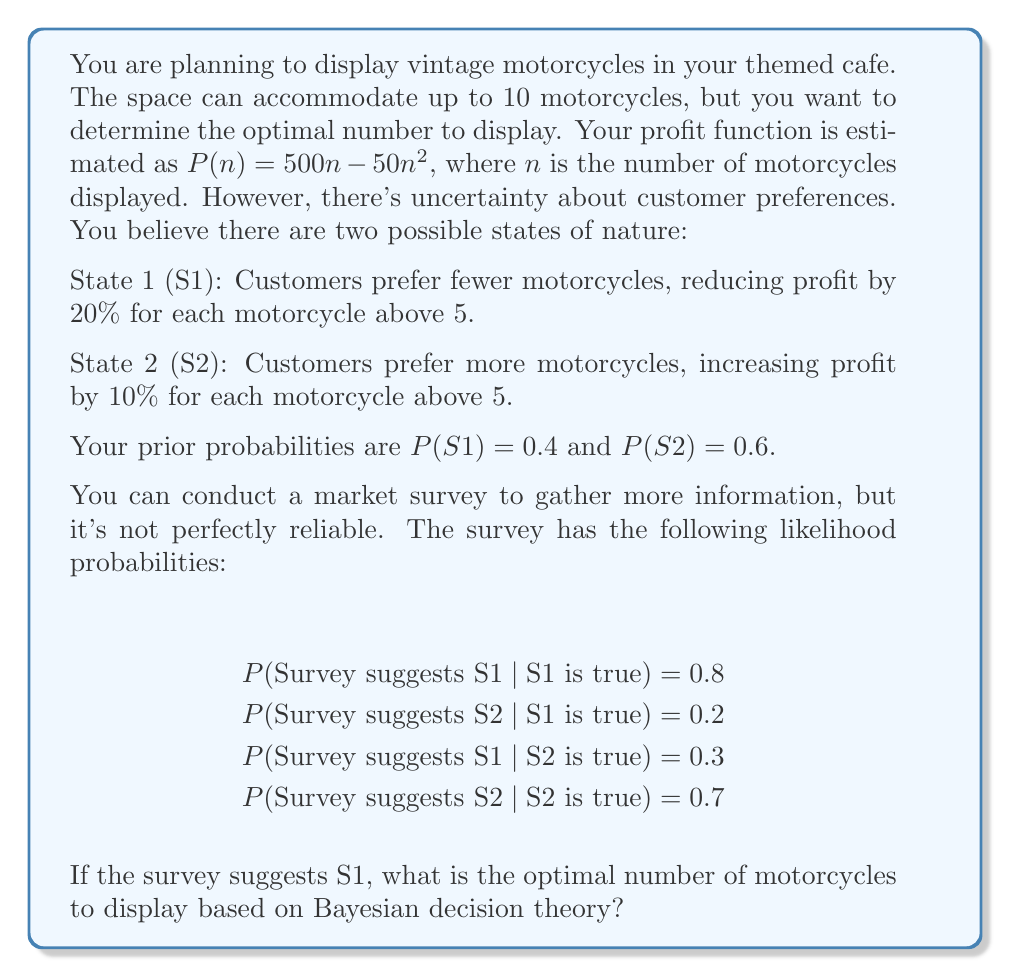Can you answer this question? To solve this problem, we'll follow these steps:

1. Calculate the posterior probabilities using Bayes' theorem
2. Determine the expected profit for each number of motorcycles
3. Find the number of motorcycles that maximizes expected profit

Step 1: Calculate posterior probabilities

Let E be the event that the survey suggests S1.

P(S1|E) = P(E|S1) * P(S1) / [P(E|S1) * P(S1) + P(E|S2) * P(S2)]
        = 0.8 * 0.4 / (0.8 * 0.4 + 0.3 * 0.6)
        ≈ 0.64

P(S2|E) = 1 - P(S1|E) ≈ 0.36

Step 2: Determine expected profit for each number of motorcycles

For n ≤ 5:
E[P(n)] = P(S1|E) * (500n - 50n^2) + P(S2|E) * (500n - 50n^2)
        = 500n - 50n^2

For n > 5:
E[P(n)] = P(S1|E) * (500n - 50n^2) * (1 - 0.2(n-5))
        + P(S2|E) * (500n - 50n^2) * (1 + 0.1(n-5))

Step 3: Find the number of motorcycles that maximizes expected profit

We need to calculate E[P(n)] for n = 1 to 10 and find the maximum value.

n = 1: E[P(1)] = 450
n = 2: E[P(2)] = 800
n = 3: E[P(3)] = 1050
n = 4: E[P(4)] = 1200
n = 5: E[P(5)] = 1250
n = 6: E[P(6)] = 0.64 * 1200 * 0.8 + 0.36 * 1200 * 1.1 ≈ 1180.80
n = 7: E[P(7)] = 0.64 * 1050 * 0.6 + 0.36 * 1050 * 1.2 ≈ 982.80
n = 8: E[P(8)] = 0.64 * 800 * 0.4 + 0.36 * 800 * 1.3 ≈ 614.40
n = 9: E[P(9)] = 0.64 * 450 * 0.2 + 0.36 * 450 * 1.4 ≈ 226.80
n = 10: E[P(10)] = 0.64 * 0 * 0 + 0.36 * 0 * 1.5 = 0

The maximum expected profit occurs when n = 5.
Answer: The optimal number of motorcycles to display is 5. 